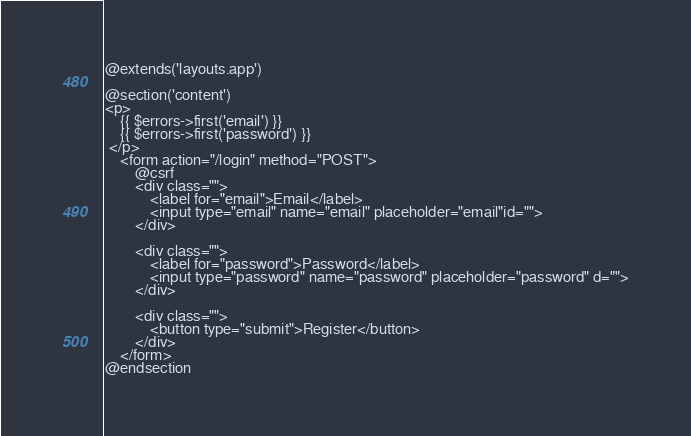Convert code to text. <code><loc_0><loc_0><loc_500><loc_500><_PHP_>@extends('layouts.app')

@section('content')
<p>
    {{ $errors->first('email') }}
    {{ $errors->first('password') }}
 </p>
    <form action="/login" method="POST">
        @csrf
        <div class="">
            <label for="email">Email</label>
            <input type="email" name="email" placeholder="email"id="">
        </div>

        <div class="">
            <label for="password">Password</label>
            <input type="password" name="password" placeholder="password" d="">
        </div>

        <div class="">
            <button type="submit">Register</button>
        </div>
    </form>
@endsection</code> 